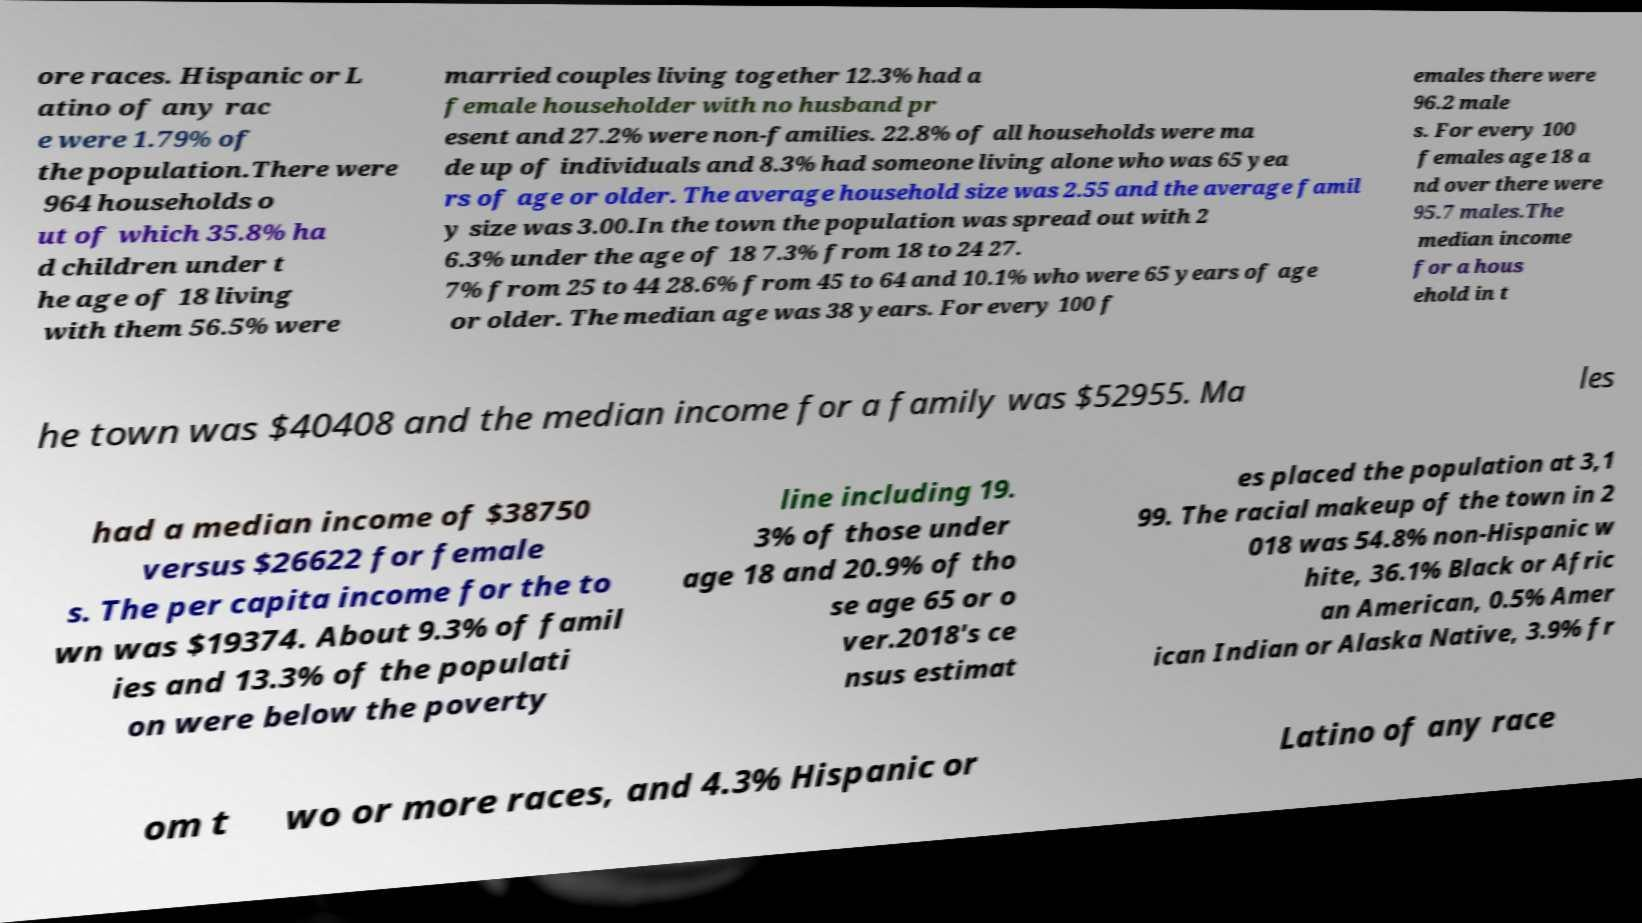Please read and relay the text visible in this image. What does it say? ore races. Hispanic or L atino of any rac e were 1.79% of the population.There were 964 households o ut of which 35.8% ha d children under t he age of 18 living with them 56.5% were married couples living together 12.3% had a female householder with no husband pr esent and 27.2% were non-families. 22.8% of all households were ma de up of individuals and 8.3% had someone living alone who was 65 yea rs of age or older. The average household size was 2.55 and the average famil y size was 3.00.In the town the population was spread out with 2 6.3% under the age of 18 7.3% from 18 to 24 27. 7% from 25 to 44 28.6% from 45 to 64 and 10.1% who were 65 years of age or older. The median age was 38 years. For every 100 f emales there were 96.2 male s. For every 100 females age 18 a nd over there were 95.7 males.The median income for a hous ehold in t he town was $40408 and the median income for a family was $52955. Ma les had a median income of $38750 versus $26622 for female s. The per capita income for the to wn was $19374. About 9.3% of famil ies and 13.3% of the populati on were below the poverty line including 19. 3% of those under age 18 and 20.9% of tho se age 65 or o ver.2018's ce nsus estimat es placed the population at 3,1 99. The racial makeup of the town in 2 018 was 54.8% non-Hispanic w hite, 36.1% Black or Afric an American, 0.5% Amer ican Indian or Alaska Native, 3.9% fr om t wo or more races, and 4.3% Hispanic or Latino of any race 